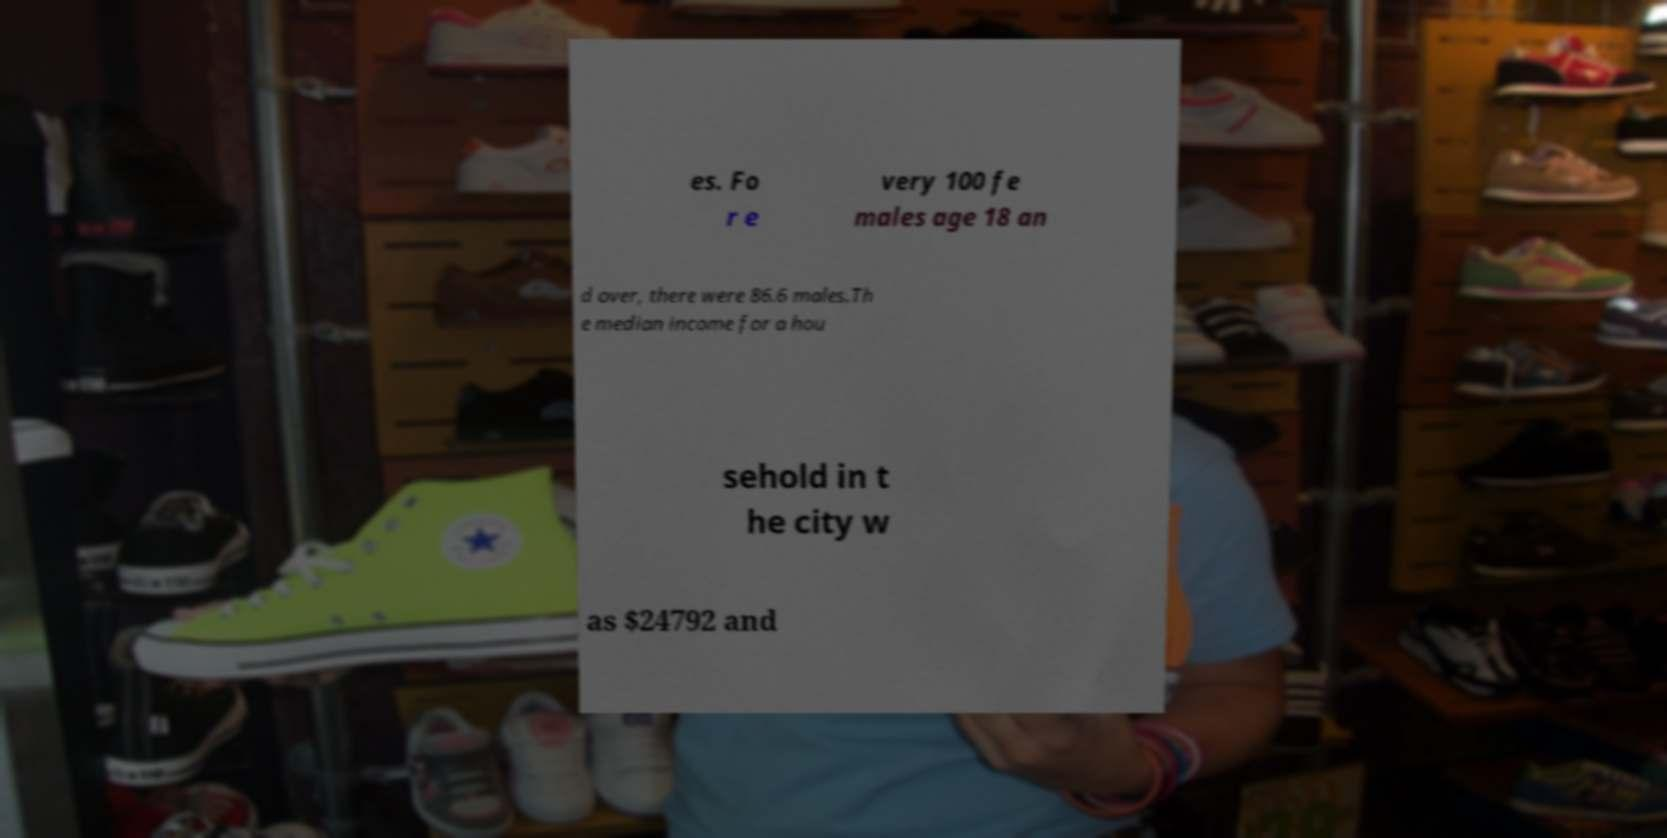What messages or text are displayed in this image? I need them in a readable, typed format. es. Fo r e very 100 fe males age 18 an d over, there were 86.6 males.Th e median income for a hou sehold in t he city w as $24792 and 